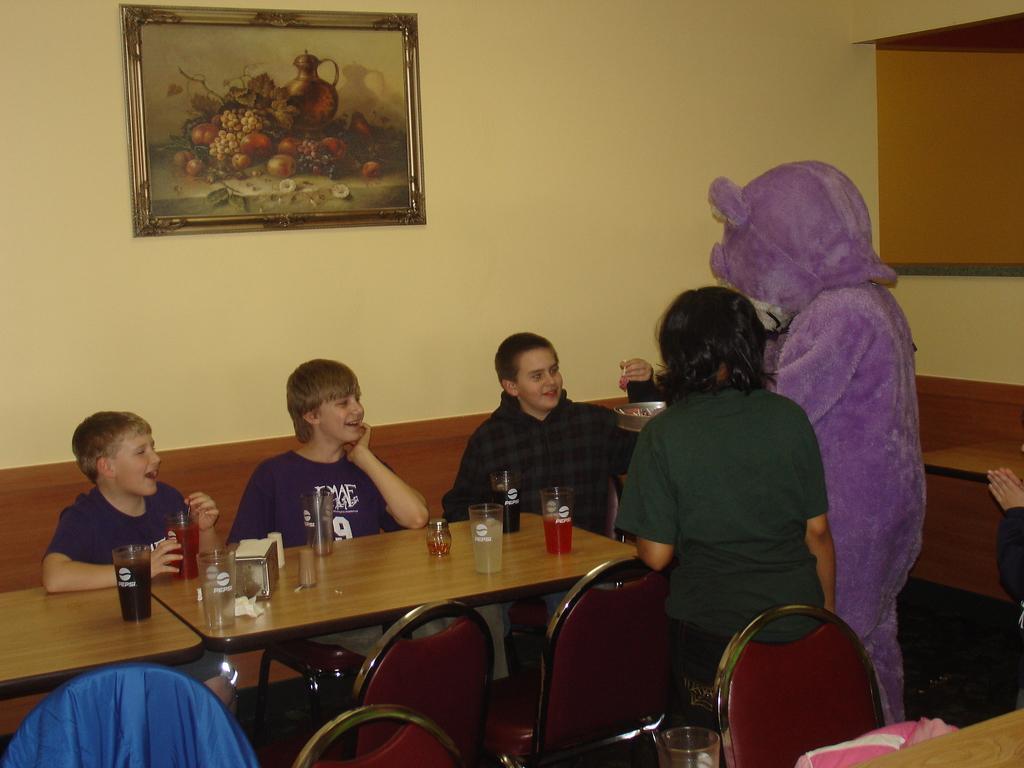Could you give a brief overview of what you see in this image? this picture shows few people seated on the sofa and two people are standing and we see few glasses on the table and a photo frame on the wall 